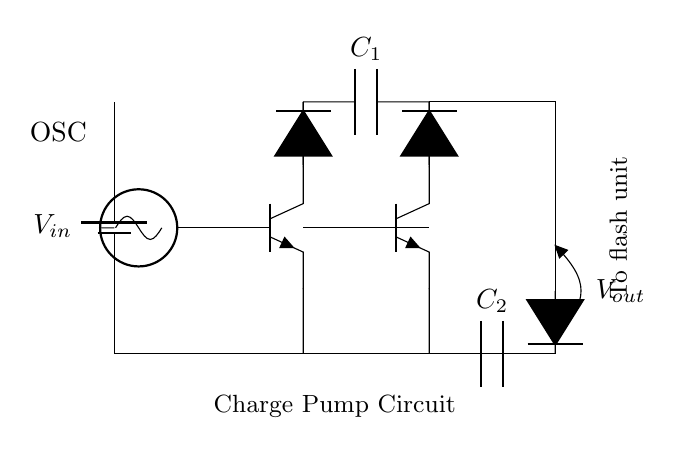what is the input voltage for the charge pump circuit? The input voltage is denoted as V_in, which is the starting voltage supplied from the battery. This is represented by the battery symbol in the circuit diagram.
Answer: V_in how many capacitors are present in the circuit? There are two capacitors indicated in the schematic. Each is labeled as C_1 and C_2, found in the diagram at different points of the circuit.
Answer: 2 which component oscillates to drive the circuit? The component that oscillates is the oscillator, denoted as OSC in the circuit. It is the component that generates the switching signals necessary for the operation of the transistors.
Answer: OSC what role do the diodes play in this circuit? The diodes in this circuit, which are labeled in the diagram, function to allow current to flow in one direction only, helping to rectify the output and charge the capacitors effectively.
Answer: Rectification explain the connection between the transistors and capacitors in the charge pump circuit. The transistors are interconnected with the capacitors to act as electronic switches. When the oscillator activates the transistors, they alternate the charging and discharging of the capacitors, thereby boosting the voltage output. This is evident from the connections shown in the circuit between the emitters and collectors of the transistors and the capacitors.
Answer: Voltage boosting what is the output voltage represented as in the circuit? The output voltage is represented as V_out, located at the terminal after the last capacitor. This specifies the voltage provided to the flash unit when the circuit is functioning.
Answer: V_out how do the two transistors affect the voltage boosting process in this charge pump circuit? The two transistors work in tandem, with one transistor activating while the other is deactivating, allowing for alternating charging of capacitors. This switching creates a voltage enhancement effect during operation, providing a higher voltage at V_out compared to the input voltage. This is derived from the need for two active devices to manage the flow and charge between capacitors during the boost operation.
Answer: Dual switching 